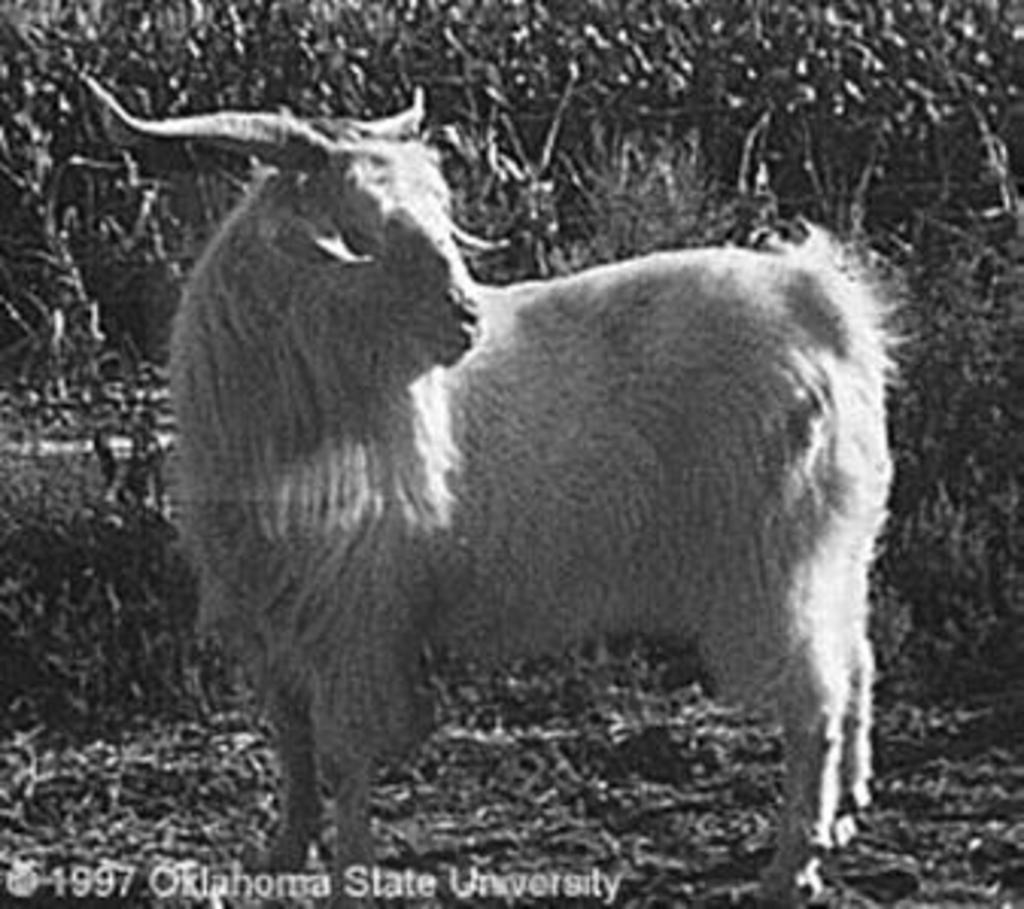How would you summarize this image in a sentence or two? In the center of the image we can see an animal. In the background there are plants. 